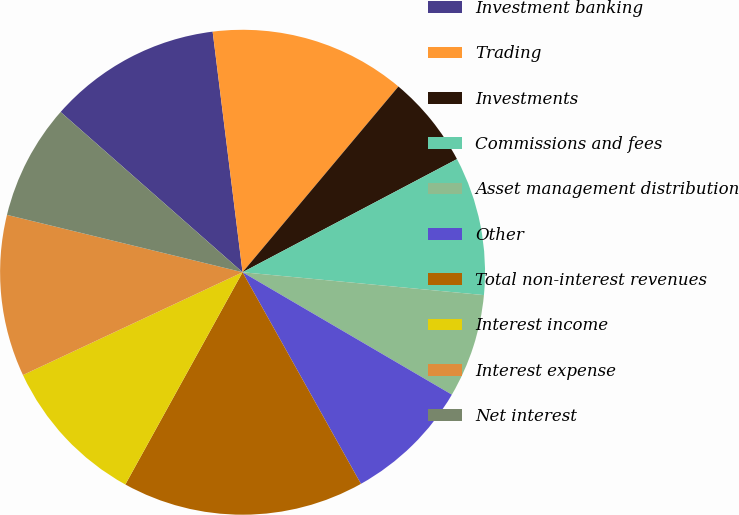<chart> <loc_0><loc_0><loc_500><loc_500><pie_chart><fcel>Investment banking<fcel>Trading<fcel>Investments<fcel>Commissions and fees<fcel>Asset management distribution<fcel>Other<fcel>Total non-interest revenues<fcel>Interest income<fcel>Interest expense<fcel>Net interest<nl><fcel>11.54%<fcel>13.08%<fcel>6.16%<fcel>9.23%<fcel>6.92%<fcel>8.46%<fcel>16.15%<fcel>10.0%<fcel>10.77%<fcel>7.69%<nl></chart> 